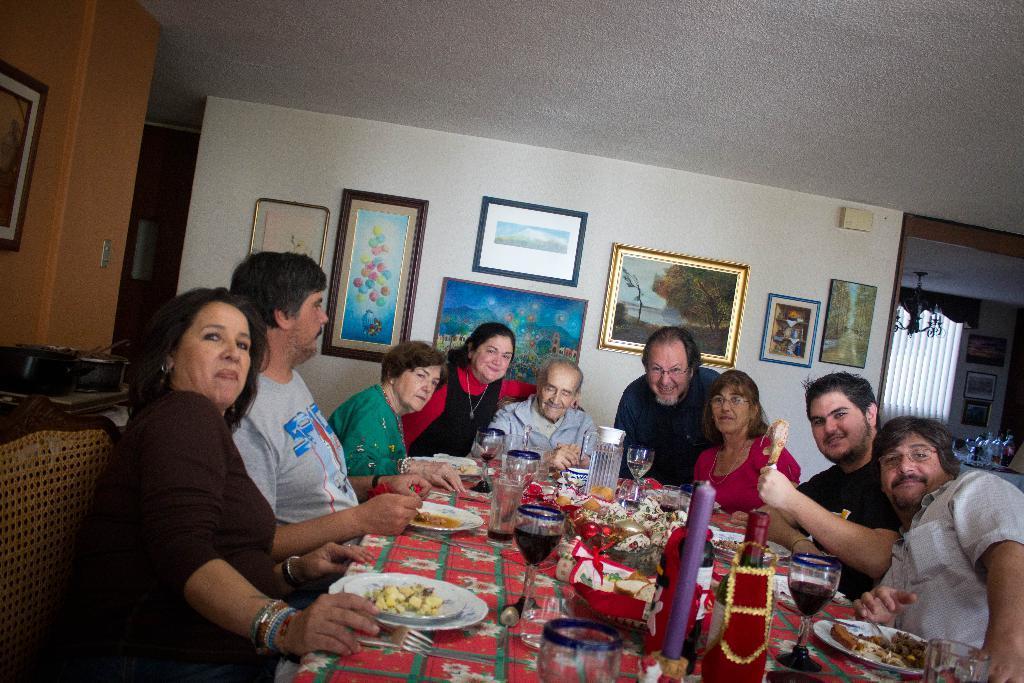How would you summarize this image in a sentence or two? In this picture there are group of people who are sitting on the chair. A man wearing a black dress is holding a chicken piece in his hand. There is a jar, glass , food in the plate , bottle, candle and other objects on the table. There is a red color cloth. There are frames on the wall. There are few glasses on the table at the background. There is a chandelier to the roof. 